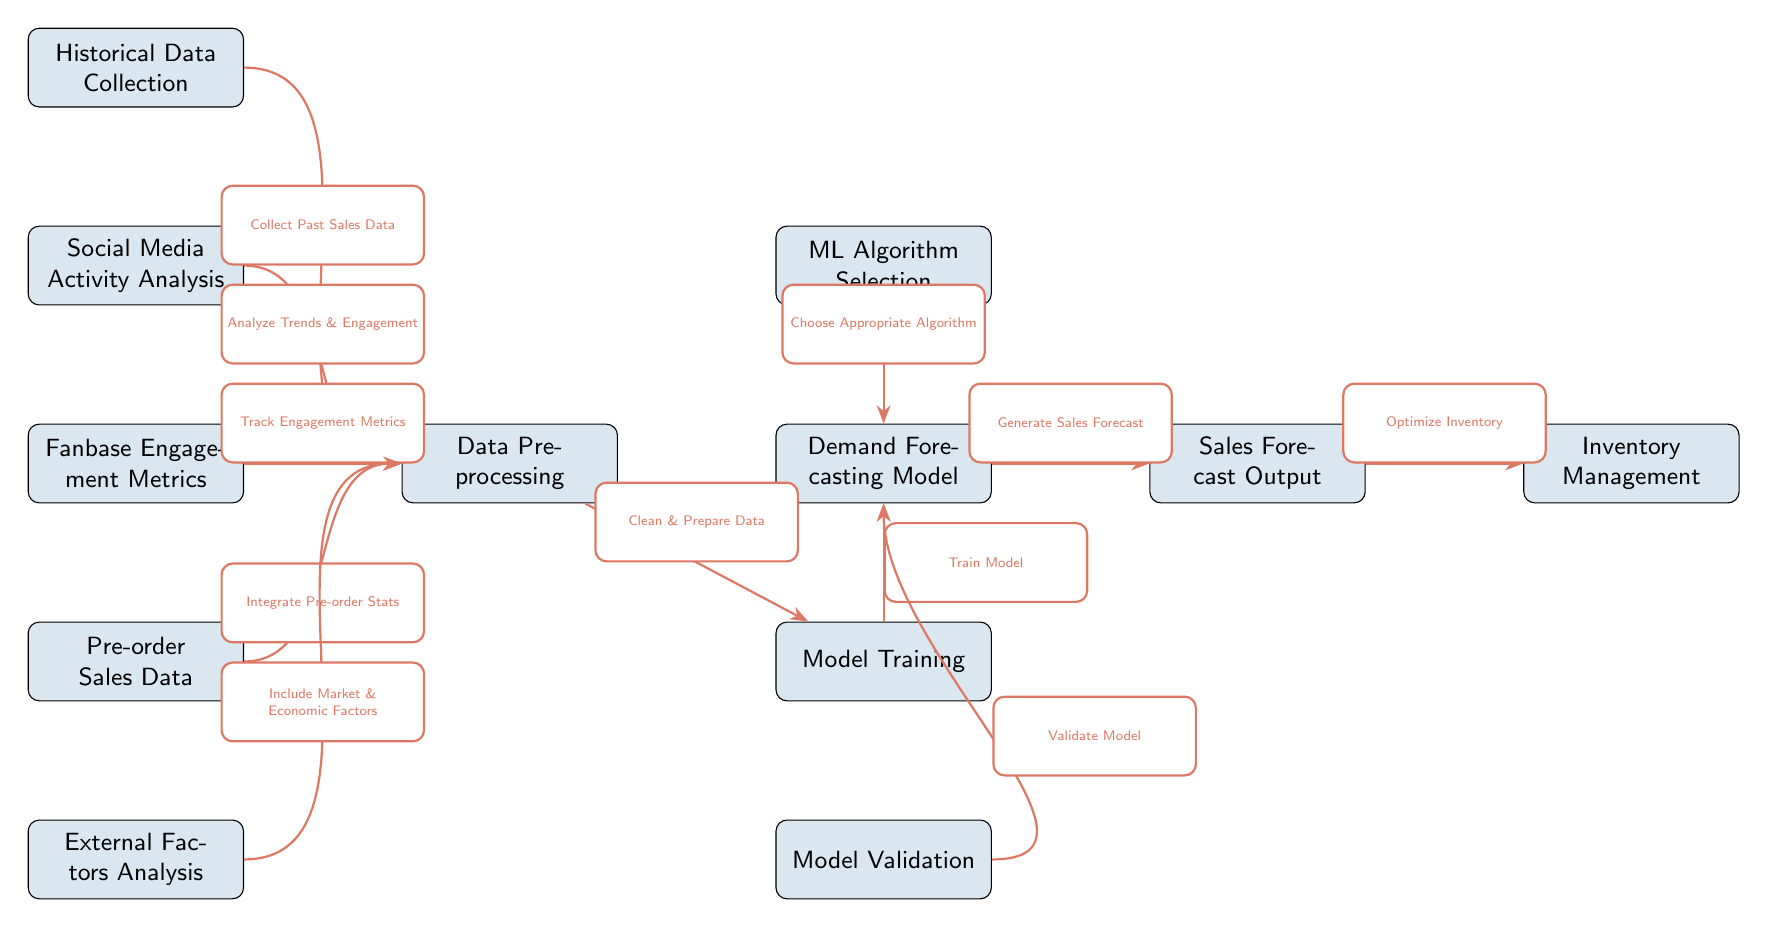What is the first node in the diagram? The diagram begins with the node labeled "Historical Data Collection" at the top.
Answer: Historical Data Collection How many nodes are in the diagram? By counting the nodes in the diagram, we find there are a total of 10 nodes present.
Answer: 10 What type of data is integrated before preprocessing? The node to the left of "Data Preprocessing" indicates "Pre-order Sales Data" is integrated before the preprocessing step.
Answer: Pre-order Sales Data What is the output of the demand forecasting model? According to the diagram, the output node is labeled "Sales Forecast Output," indicating this is the result generated by the model.
Answer: Sales Forecast Output What step follows model training in the diagram? The diagram shows that after "Model Training," the next step is "Model Validation." Therefore, this is the immediate next step.
Answer: Model Validation Which nodes contribute data to the preprocessing node? The nodes "Historical Data Collection," "Social Media Activity Analysis," "Fanbase Engagement Metrics," "Pre-order Sales Data," and "External Factors Analysis" all send data to the preprocessing node.
Answer: Five nodes What action is taken after generating the sales forecast? The diagram indicates that after generating the sales forecast, the next action is to "Optimize Inventory." Thus, that is the immediate follow-up action.
Answer: Optimize Inventory Which node represents the analysis of fanbase metrics? The node labeled "Fanbase Engagement Metrics" signifies the analysis of fanbase engagement and is part of the data inputs before preprocessing.
Answer: Fanbase Engagement Metrics What is the relationship between the "ML Algorithm Selection" and the "Demand Forecasting Model"? The diagram specifies that the "ML Algorithm Selection" chooses an appropriate algorithm, which directly feeds into the "Demand Forecasting Model." Therefore, the relationship is that the algorithm selection influences the model creation.
Answer: Choose Appropriate Algorithm 